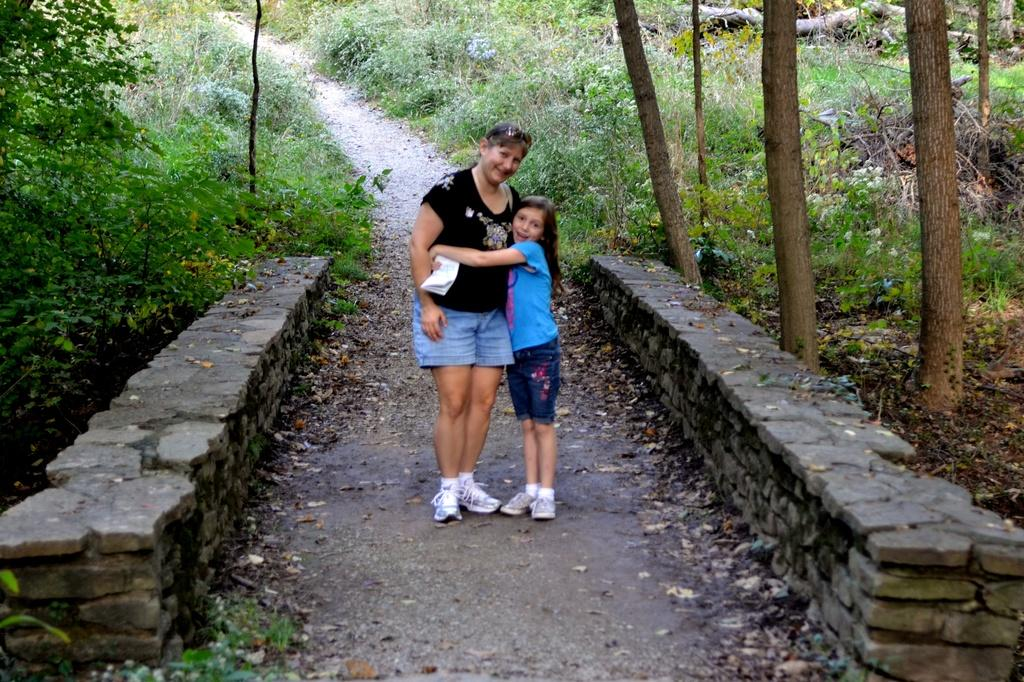How many people are in the image? There are a few people in the image. What can be seen under the people's feet in the image? The ground is visible in the image. What type of structure is present in the image? There is a stone wall in the image. What type of vegetation is present in the image? There are plants and trees in the image. What type of ground cover is visible in the image? There is grass visible in the image. What type of disease is affecting the plants in the image? There is no indication of any disease affecting the plants in the image; they appear healthy. 